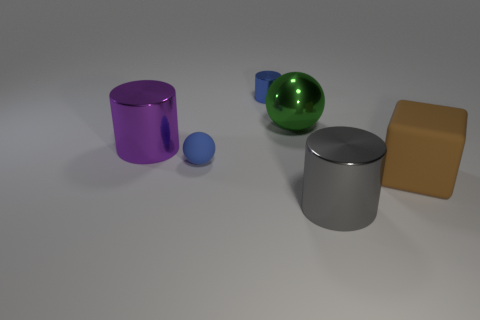There is a blue object that is made of the same material as the purple thing; what is its size?
Provide a succinct answer. Small. Is there any other thing that has the same color as the big metal ball?
Give a very brief answer. No. Is the gray cylinder made of the same material as the sphere on the right side of the tiny blue matte sphere?
Give a very brief answer. Yes. What material is the tiny object that is the same shape as the large green metal thing?
Your answer should be very brief. Rubber. Is the small blue thing in front of the tiny shiny object made of the same material as the large block that is to the right of the purple thing?
Provide a short and direct response. Yes. There is a small object in front of the cylinder on the left side of the sphere that is in front of the large metal sphere; what color is it?
Offer a very short reply. Blue. What number of other objects are the same shape as the brown matte object?
Give a very brief answer. 0. Is the tiny shiny thing the same color as the small ball?
Your answer should be very brief. Yes. What number of things are either matte objects or things behind the small blue ball?
Offer a very short reply. 5. Is there a metallic object of the same size as the green metal sphere?
Ensure brevity in your answer.  Yes. 